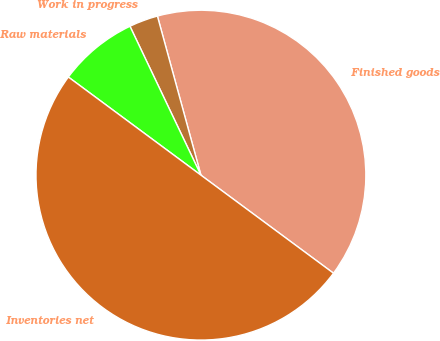Convert chart to OTSL. <chart><loc_0><loc_0><loc_500><loc_500><pie_chart><fcel>Finished goods<fcel>Work in progress<fcel>Raw materials<fcel>Inventories net<nl><fcel>39.38%<fcel>2.83%<fcel>7.78%<fcel>50.0%<nl></chart> 